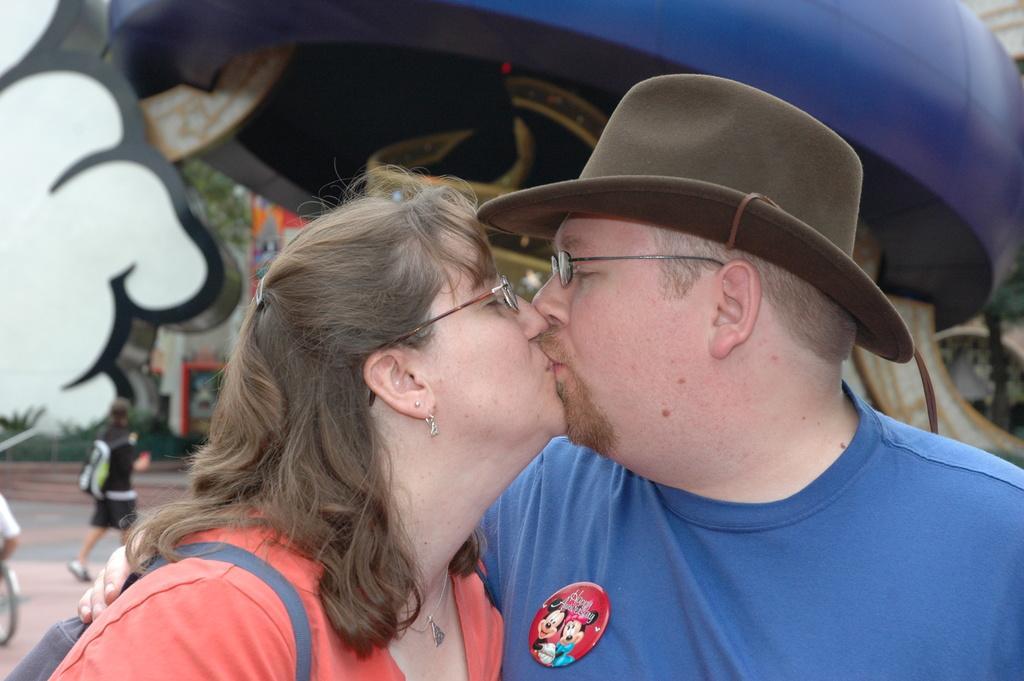Describe this image in one or two sentences. In front of the picture, we see a man and the women are kissing each other. They are wearing the spectacles. The man is wearing a hat. Behind them, we see a man who is wearing the backpack is walking on the road. On the left side, we see the bicycle. At the top, we see something in blue color. In the background, we see a tree, building and some other objects. This picture is blurred in the background. 